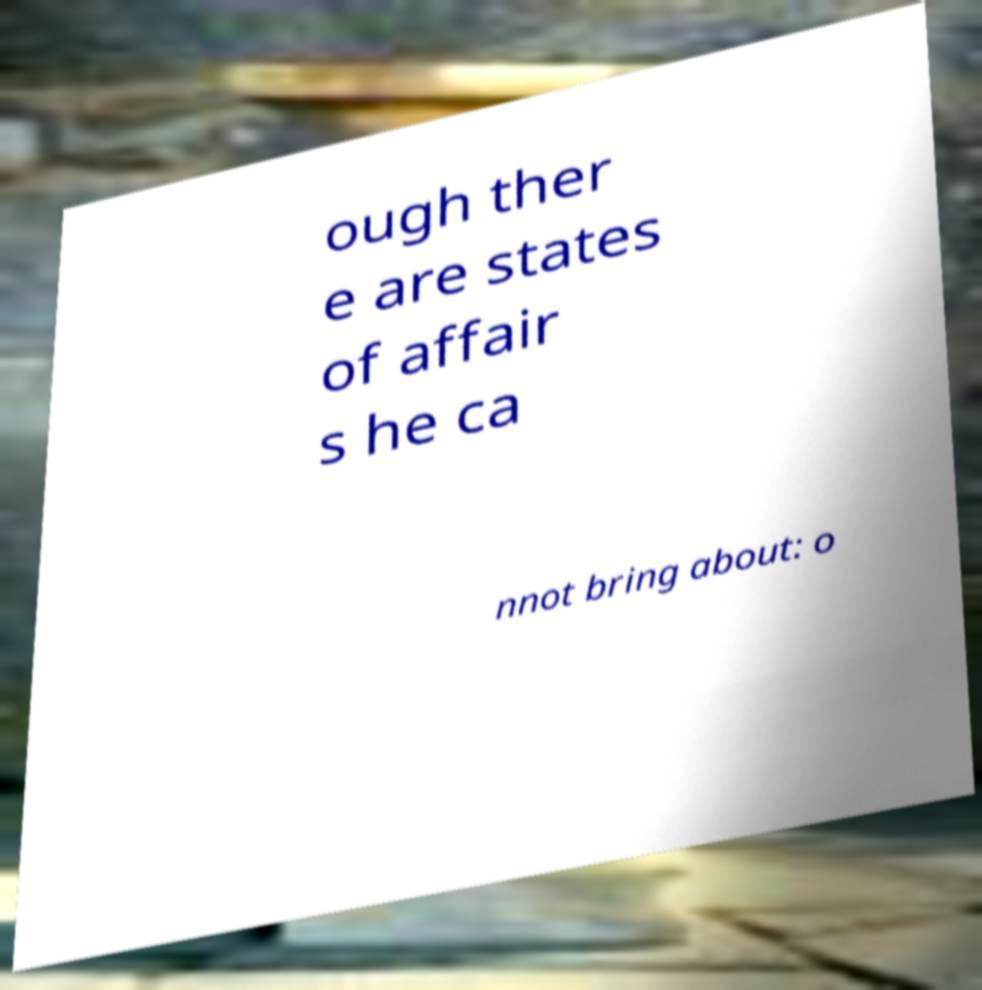Can you read and provide the text displayed in the image?This photo seems to have some interesting text. Can you extract and type it out for me? ough ther e are states of affair s he ca nnot bring about: o 